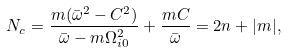Convert formula to latex. <formula><loc_0><loc_0><loc_500><loc_500>N _ { c } = \frac { m ( \bar { \omega } ^ { 2 } - C ^ { 2 } ) } { \bar { \omega } - m \Omega _ { i 0 } ^ { 2 } } + \frac { m C } { \bar { \omega } } = 2 n + | m | ,</formula> 